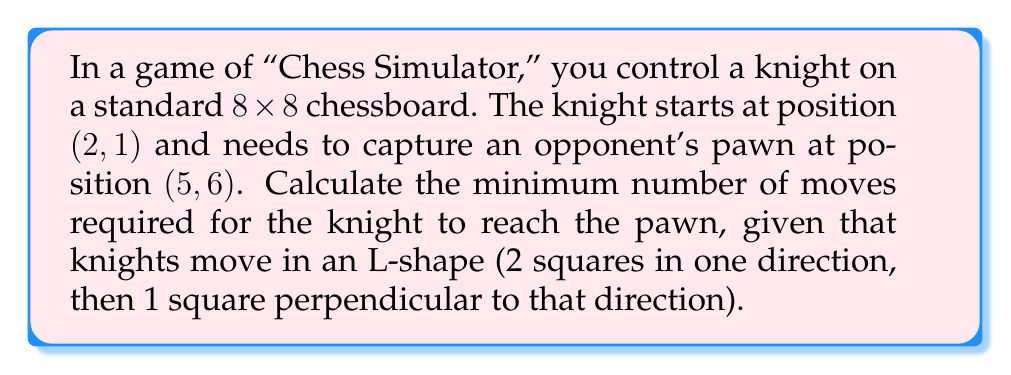Can you answer this question? Let's approach this step-by-step:

1) First, we need to understand the knight's movement. It can move:
   $$(x \pm 1, y \pm 2)$$ or $$(x \pm 2, y \pm 1)$$

2) We can represent the chessboard as a coordinate system where (2, 1) is the starting position and (5, 6) is the target position.

3) To find the optimal path, we can use a breadth-first search (BFS) algorithm, which guarantees the shortest path in an unweighted graph.

4) Let's visualize the knight's possible moves:

   [asy]
   unitsize(0.5cm);
   for(int i=0; i<9; ++i) {
     draw((i,0)--(i,8),gray);
     draw((0,i)--(8,i),gray);
   }
   dot((2,1),red);
   dot((5,6),blue);
   label("Start",(2,1),SW,red);
   label("Target",(5,6),NE,blue);
   [/asy]

5) Using BFS, we explore moves level by level:
   - Level 1: (1,3), (3,3), (4,2), (4,0)
   - Level 2: (2,5), (3,5), (5,4), (6,4), (5,1), (6,2), ...
   - Level 3: (4,7), (5,6), ...

6) We reach (5,6) at level 3, which means it takes 3 moves.

7) One possible optimal path is:
   (2,1) -> (3,3) -> (4,5) -> (5,6)
Answer: 3 moves 